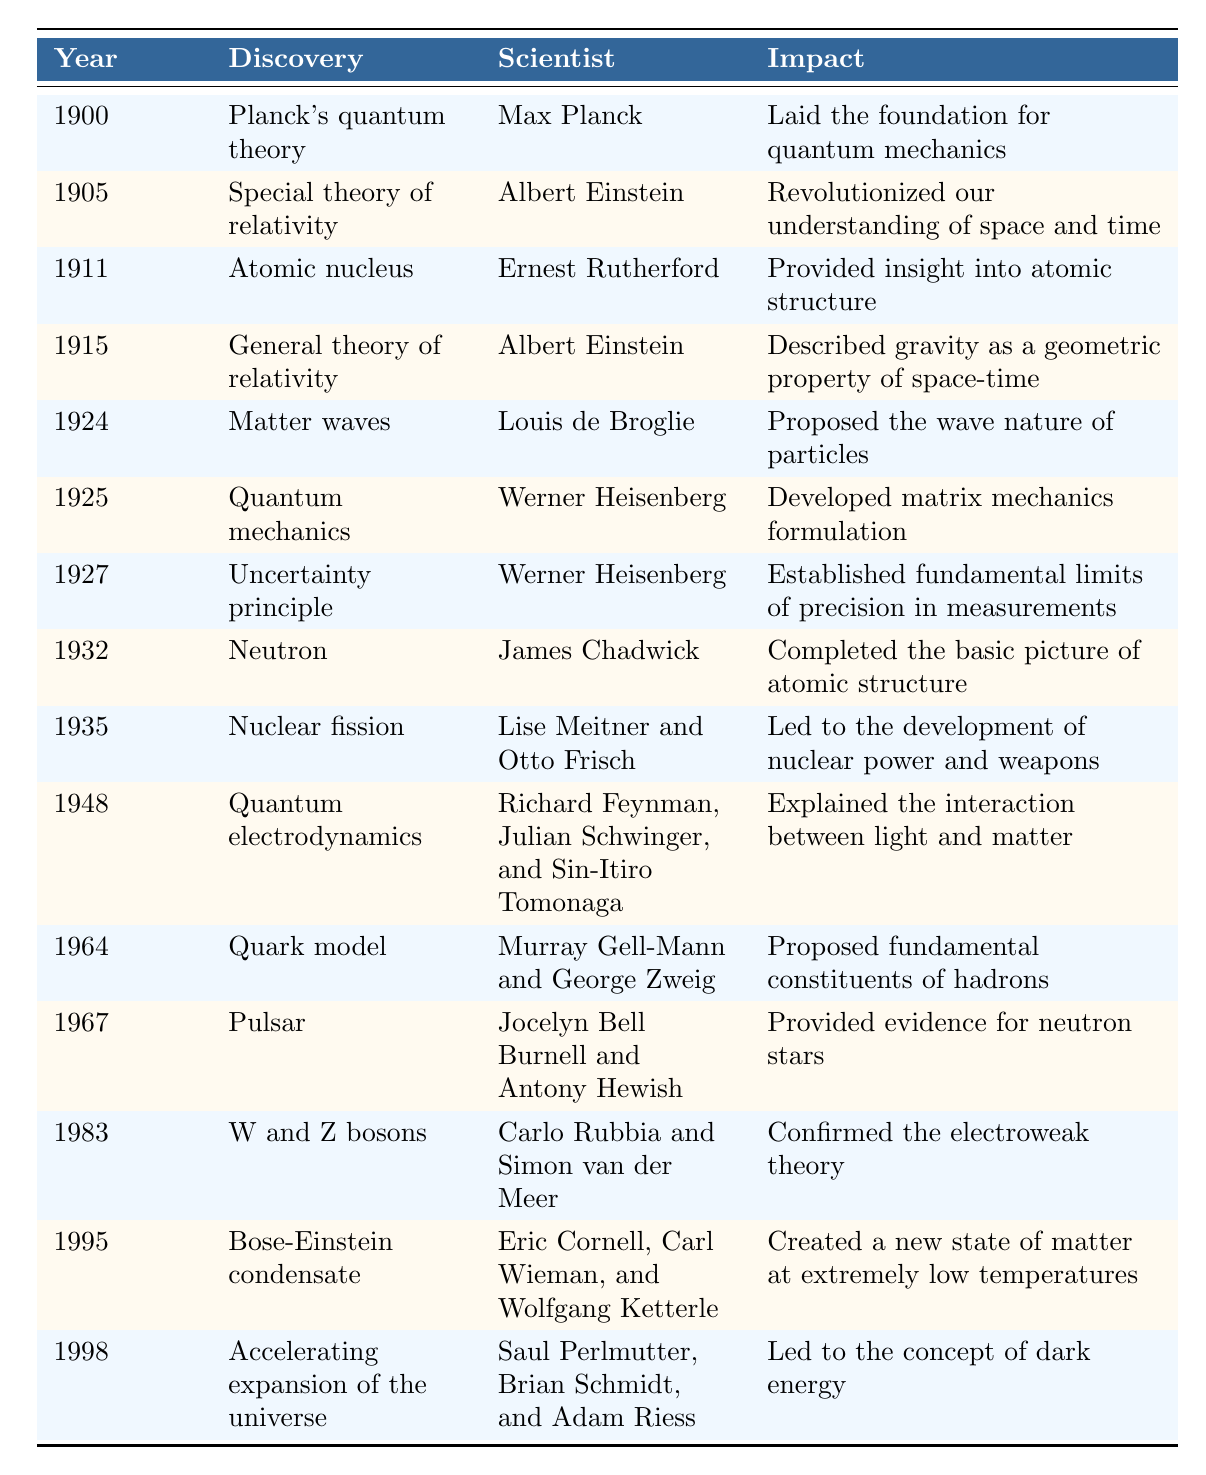What discovery did Max Planck make in 1900? The table indicates that in 1900, Max Planck made the discovery of "Planck's quantum theory."
Answer: Planck's quantum theory Which discovery occurred in 1915? Referring to the table, the discovery listed for 1915 is the "General theory of relativity" made by Albert Einstein.
Answer: General theory of relativity Who were the scientists responsible for the discovery of nuclear fission? According to the table, the discovery of nuclear fission was made by Lise Meitner and Otto Frisch in 1935.
Answer: Lise Meitner and Otto Frisch How many discoveries were made by Albert Einstein? To find the answer, we need to count the instances of Albert Einstein in the table: he appears for "Special theory of relativity" in 1905 and "General theory of relativity" in 1915. This gives a total of 2 discoveries.
Answer: 2 Is the Uncertainty principle established by Werner Heisenberg? The table confirms that the Uncertainty principle was established by Werner Heisenberg in 1927, indicating that this statement is true.
Answer: Yes What impact did the discovery of the neutron have on our understanding of atomic structure? The table states that the discovery of the neutron completed the basic picture of atomic structure, enhancing our knowledge in this field.
Answer: Completed the basic picture of atomic structure What is the earliest discovery mentioned in the table? Checking the timeline presented, the earliest discovery is "Planck's quantum theory" from the year 1900.
Answer: Planck's quantum theory List the year in which quarks were proposed as fundamental constituents. In the table, the "Quark model" was proposed in the year 1964 by Murray Gell-Mann and George Zweig.
Answer: 1964 What was the impact of discovering the Bose-Einstein condensate? The table mentions that the discovery of the Bose-Einstein condensate created a new state of matter at extremely low temperatures, indicating its significant impact.
Answer: Created a new state of matter at extremely low temperatures 